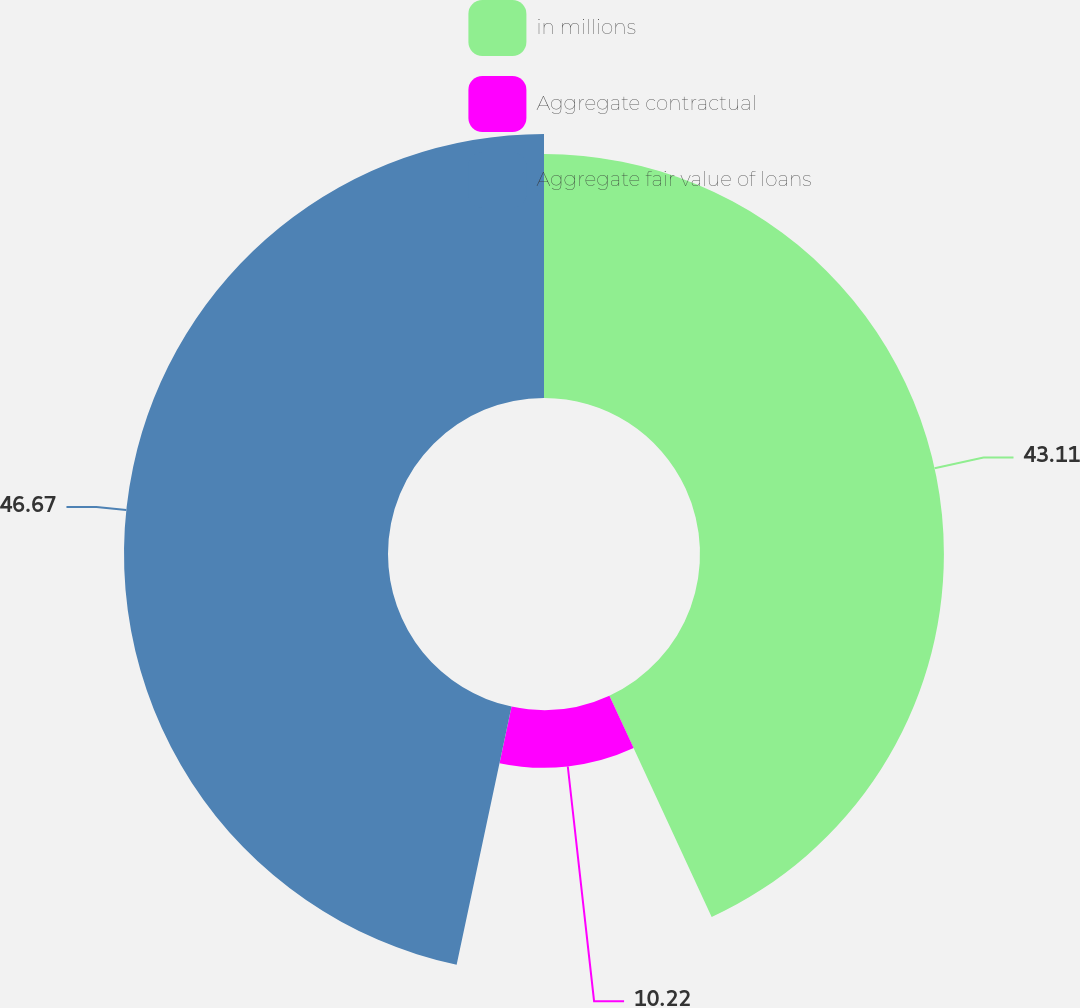Convert chart to OTSL. <chart><loc_0><loc_0><loc_500><loc_500><pie_chart><fcel>in millions<fcel>Aggregate contractual<fcel>Aggregate fair value of loans<nl><fcel>43.11%<fcel>10.22%<fcel>46.66%<nl></chart> 